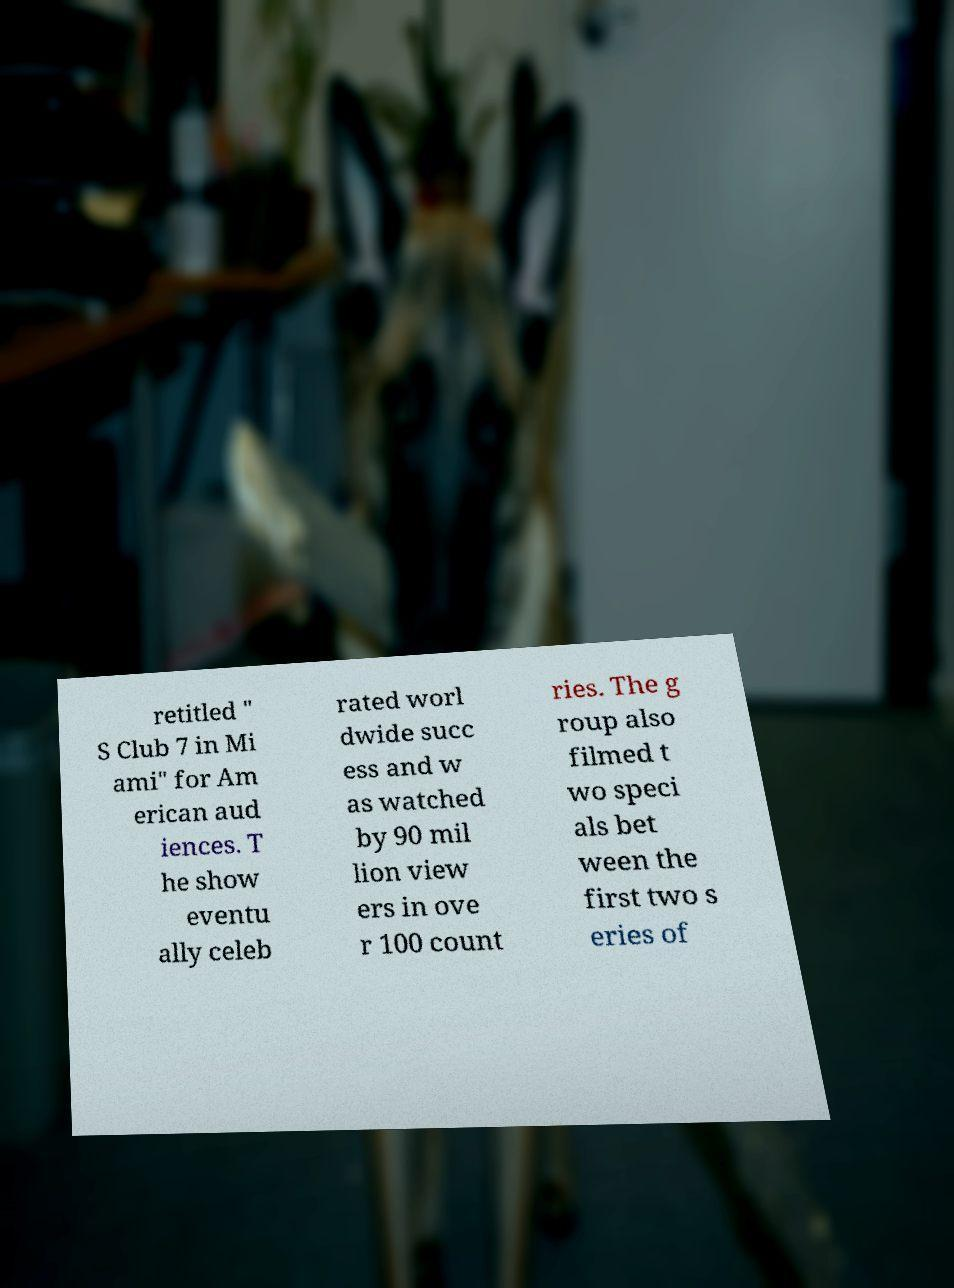Could you extract and type out the text from this image? retitled " S Club 7 in Mi ami" for Am erican aud iences. T he show eventu ally celeb rated worl dwide succ ess and w as watched by 90 mil lion view ers in ove r 100 count ries. The g roup also filmed t wo speci als bet ween the first two s eries of 